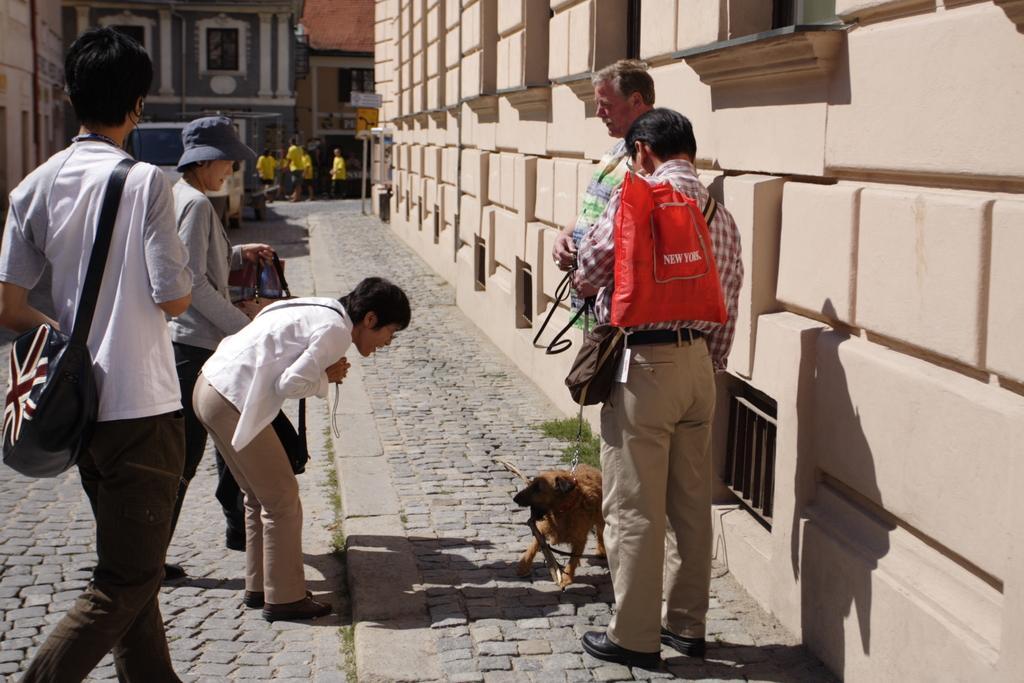Can you describe this image briefly? In this picture there are people on the road where at the right corner two people are standing on the footpath and in front of them there is a dog and left corner there are three people standing where one person is wearing a bag and another person is bending in front of the dog and in the middle there are people wearing yellow dresses and there are some buildings in the picture. 